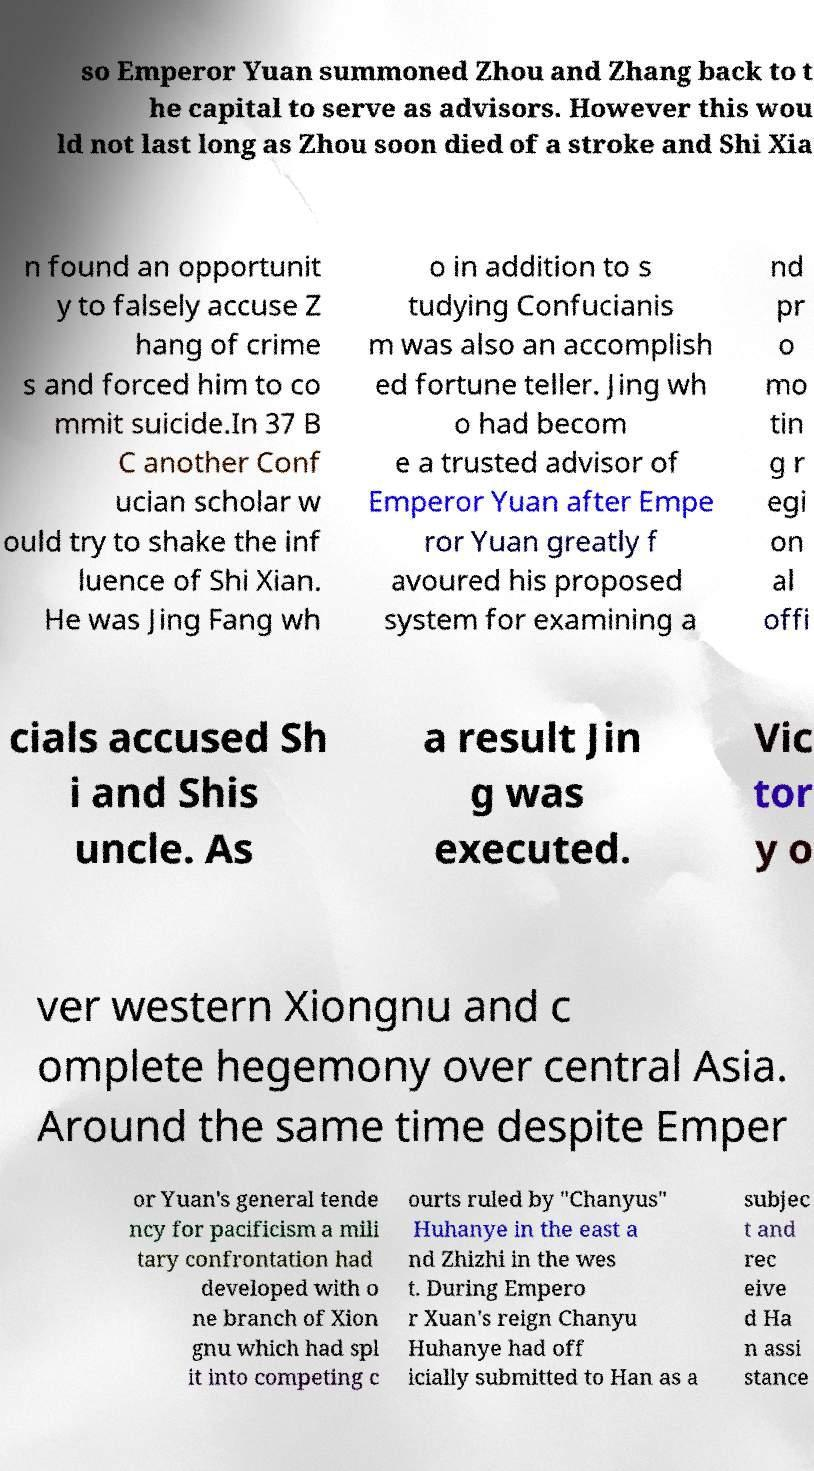Please read and relay the text visible in this image. What does it say? so Emperor Yuan summoned Zhou and Zhang back to t he capital to serve as advisors. However this wou ld not last long as Zhou soon died of a stroke and Shi Xia n found an opportunit y to falsely accuse Z hang of crime s and forced him to co mmit suicide.In 37 B C another Conf ucian scholar w ould try to shake the inf luence of Shi Xian. He was Jing Fang wh o in addition to s tudying Confucianis m was also an accomplish ed fortune teller. Jing wh o had becom e a trusted advisor of Emperor Yuan after Empe ror Yuan greatly f avoured his proposed system for examining a nd pr o mo tin g r egi on al offi cials accused Sh i and Shis uncle. As a result Jin g was executed. Vic tor y o ver western Xiongnu and c omplete hegemony over central Asia. Around the same time despite Emper or Yuan's general tende ncy for pacificism a mili tary confrontation had developed with o ne branch of Xion gnu which had spl it into competing c ourts ruled by "Chanyus" Huhanye in the east a nd Zhizhi in the wes t. During Empero r Xuan's reign Chanyu Huhanye had off icially submitted to Han as a subjec t and rec eive d Ha n assi stance 